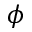Convert formula to latex. <formula><loc_0><loc_0><loc_500><loc_500>\phi</formula> 